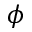Convert formula to latex. <formula><loc_0><loc_0><loc_500><loc_500>\phi</formula> 